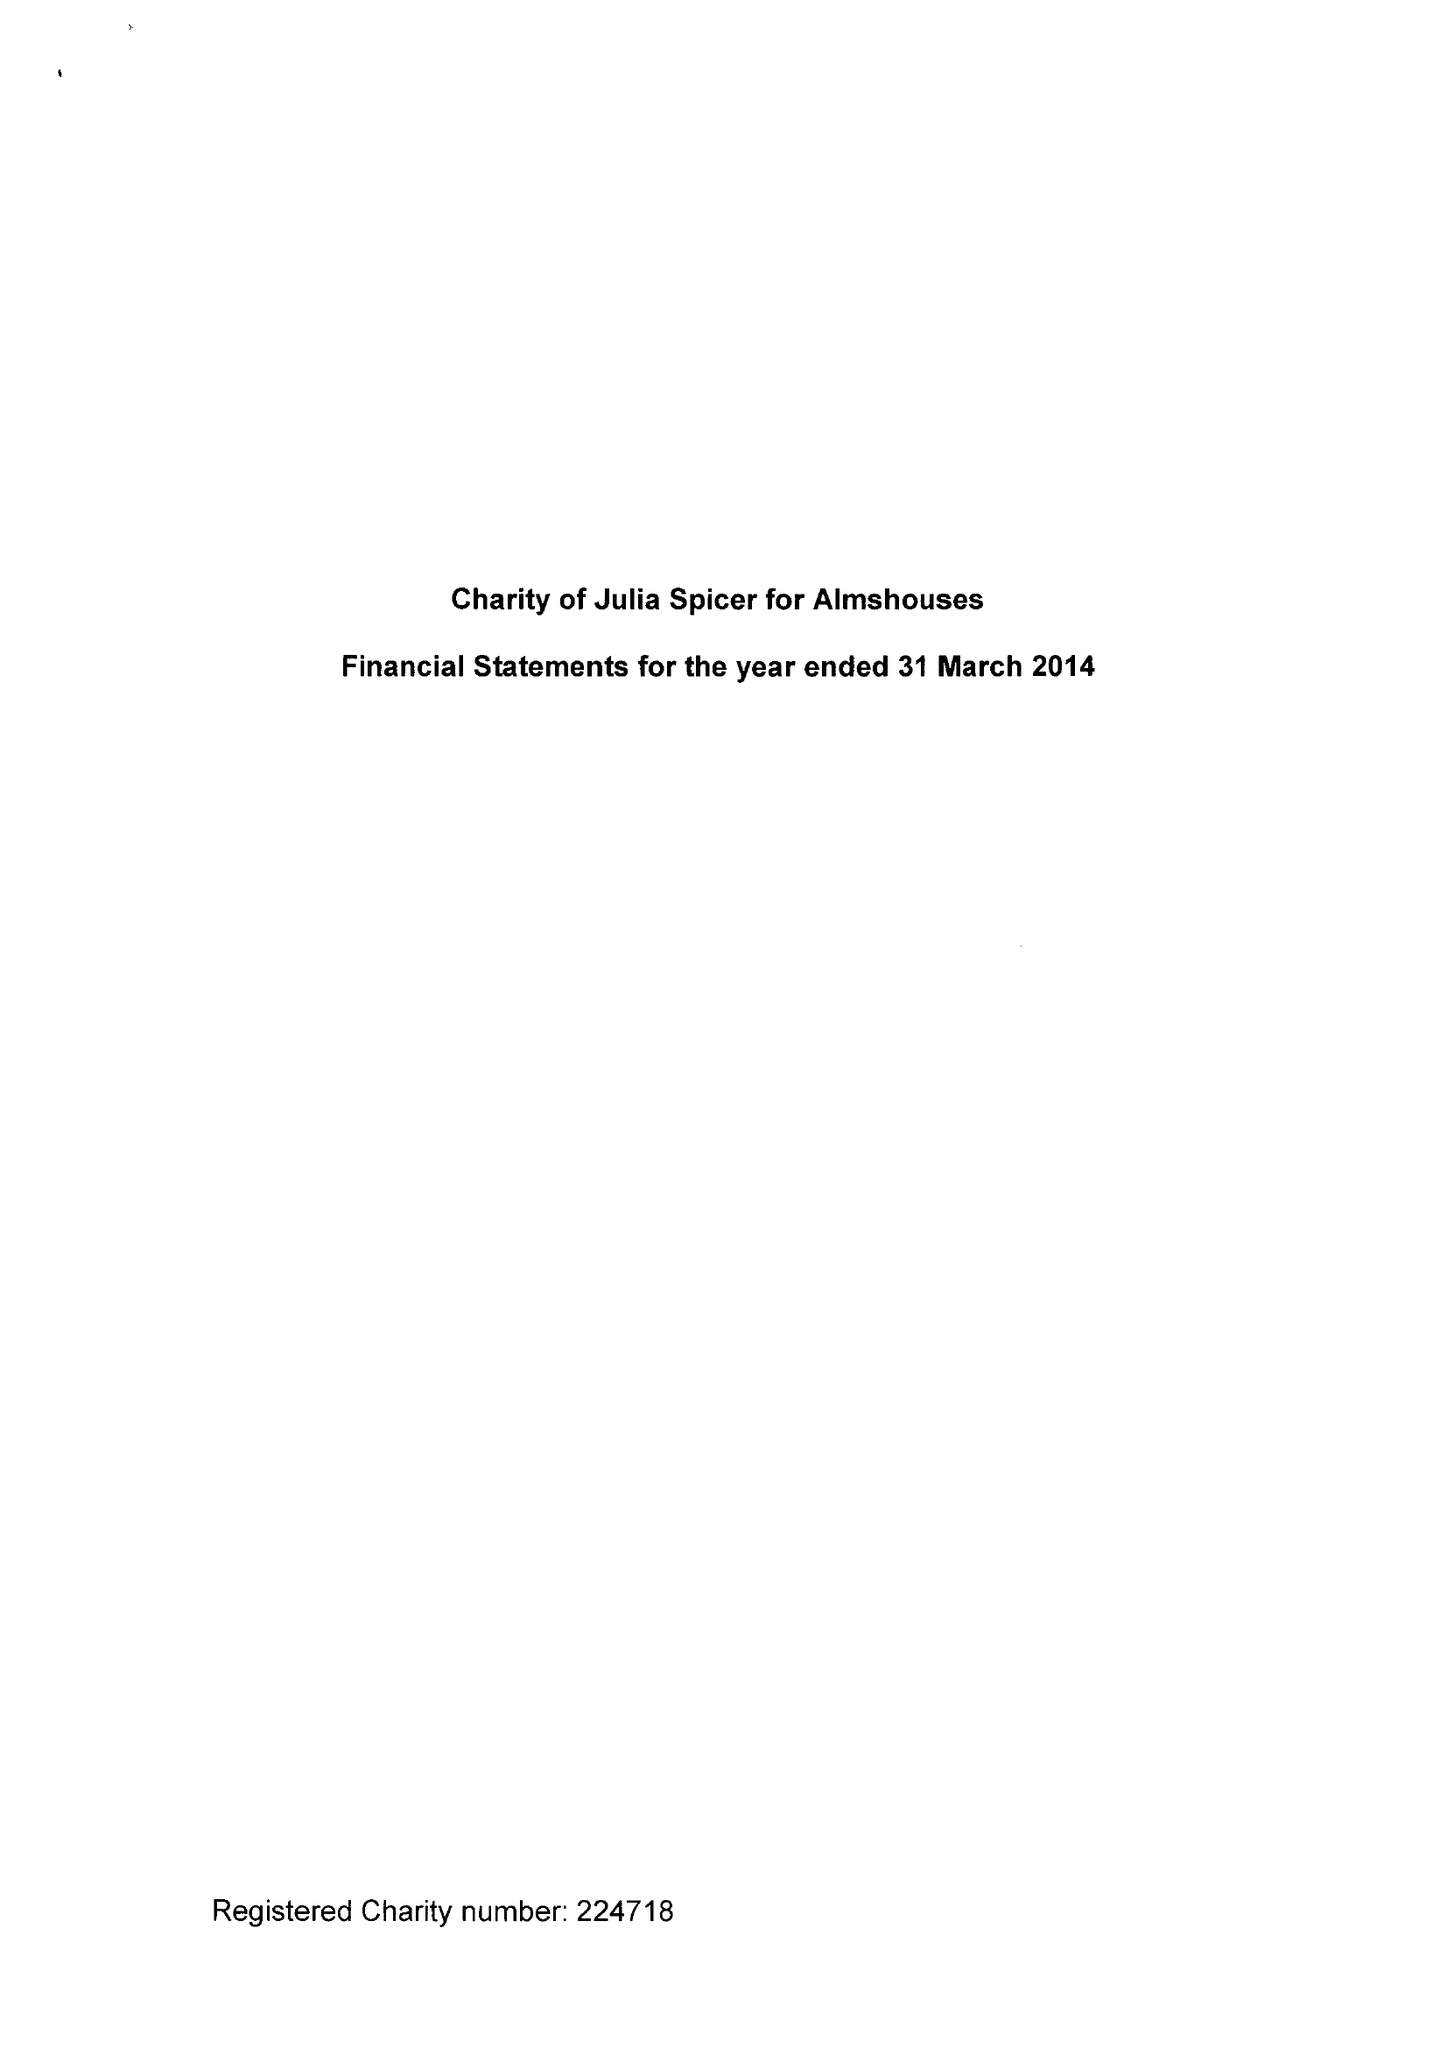What is the value for the address__street_line?
Answer the question using a single word or phrase. 125 HIGH STREET 